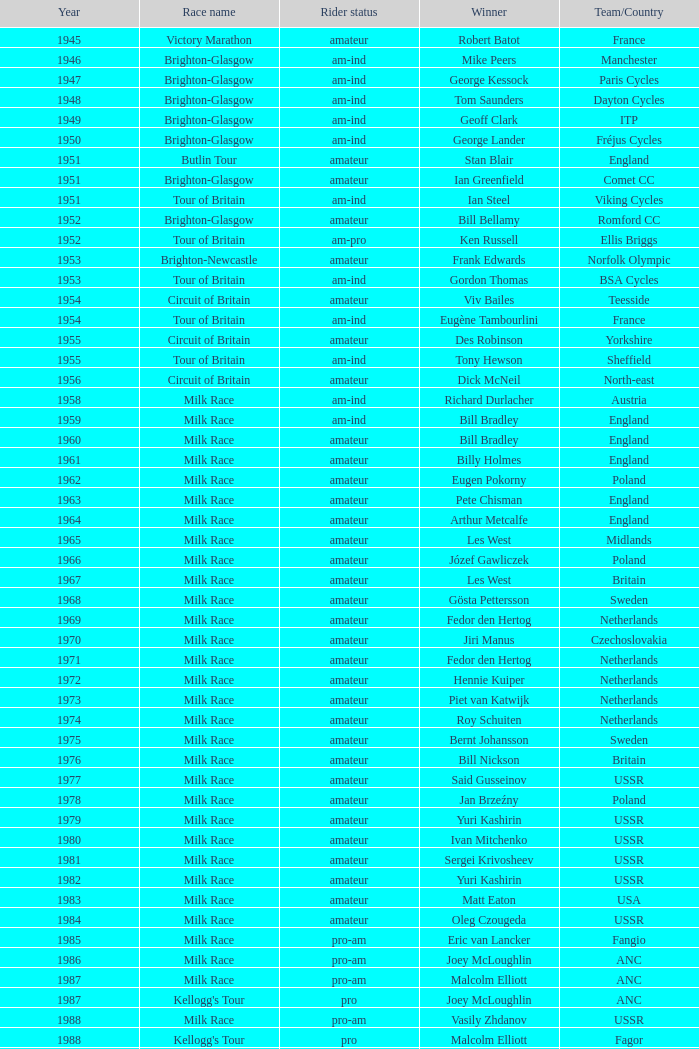In which most recent year did phil anderson achieve a victory? 1993.0. 